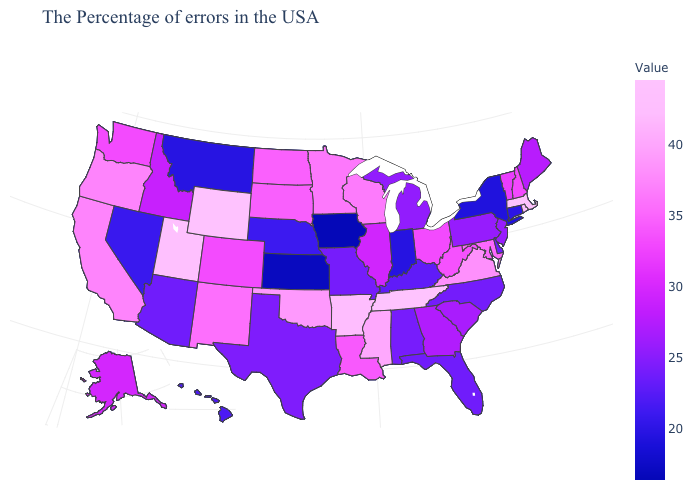Which states hav the highest value in the South?
Concise answer only. Tennessee. Which states hav the highest value in the Northeast?
Write a very short answer. Massachusetts. Does the map have missing data?
Keep it brief. No. Among the states that border Virginia , which have the highest value?
Write a very short answer. Tennessee. Does Louisiana have a lower value than Alabama?
Short answer required. No. Does Iowa have the lowest value in the USA?
Give a very brief answer. Yes. 